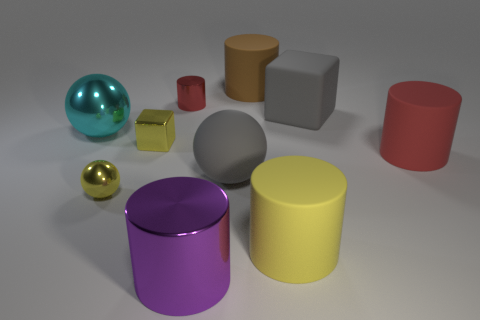Subtract 2 balls. How many balls are left? 1 Subtract all red cylinders. Subtract all purple spheres. How many cylinders are left? 3 Subtract all blocks. How many objects are left? 8 Add 5 big blocks. How many big blocks exist? 6 Subtract 0 green balls. How many objects are left? 10 Subtract all tiny yellow shiny spheres. Subtract all big metal objects. How many objects are left? 7 Add 5 tiny shiny objects. How many tiny shiny objects are left? 8 